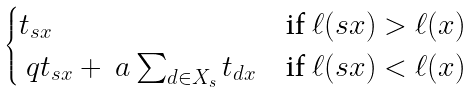Convert formula to latex. <formula><loc_0><loc_0><loc_500><loc_500>\begin{cases} t _ { s x } & \text {if $\ell(sx)>\ell(x)$} \\ \ q t _ { s x } + \ a \sum _ { d \in X _ { s } } t _ { d x } & \text {if     $\ell(sx)<\ell(x)$} \end{cases}</formula> 